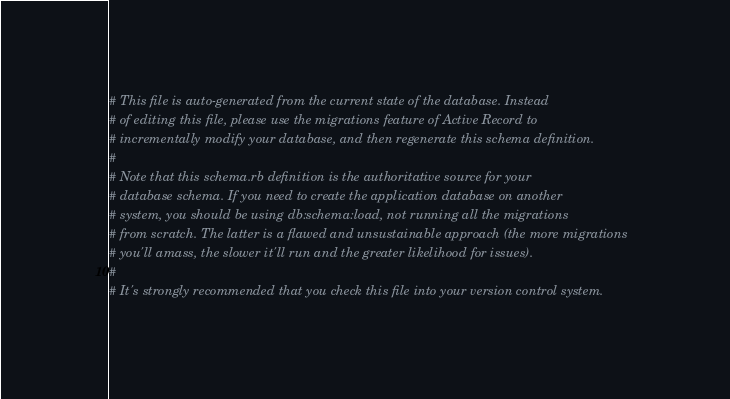<code> <loc_0><loc_0><loc_500><loc_500><_Ruby_># This file is auto-generated from the current state of the database. Instead
# of editing this file, please use the migrations feature of Active Record to
# incrementally modify your database, and then regenerate this schema definition.
#
# Note that this schema.rb definition is the authoritative source for your
# database schema. If you need to create the application database on another
# system, you should be using db:schema:load, not running all the migrations
# from scratch. The latter is a flawed and unsustainable approach (the more migrations
# you'll amass, the slower it'll run and the greater likelihood for issues).
#
# It's strongly recommended that you check this file into your version control system.
</code> 